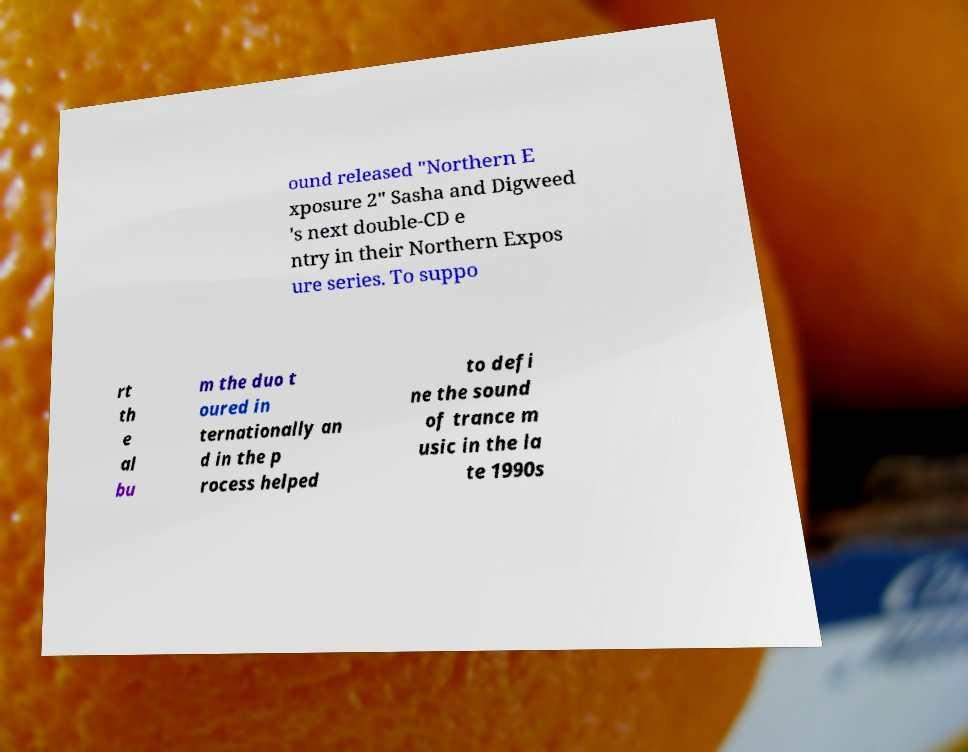Can you accurately transcribe the text from the provided image for me? ound released "Northern E xposure 2" Sasha and Digweed 's next double-CD e ntry in their Northern Expos ure series. To suppo rt th e al bu m the duo t oured in ternationally an d in the p rocess helped to defi ne the sound of trance m usic in the la te 1990s 